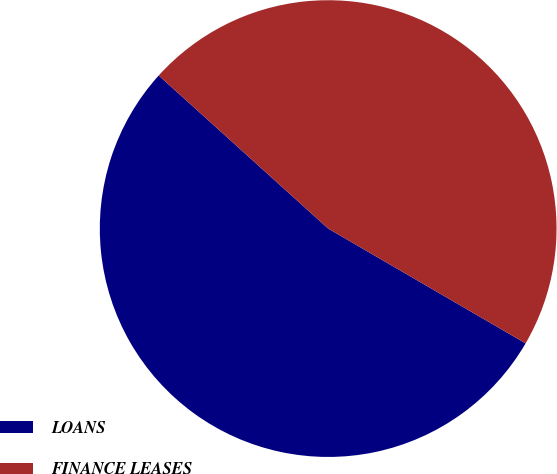Convert chart to OTSL. <chart><loc_0><loc_0><loc_500><loc_500><pie_chart><fcel>LOANS<fcel>FINANCE LEASES<nl><fcel>53.31%<fcel>46.69%<nl></chart> 